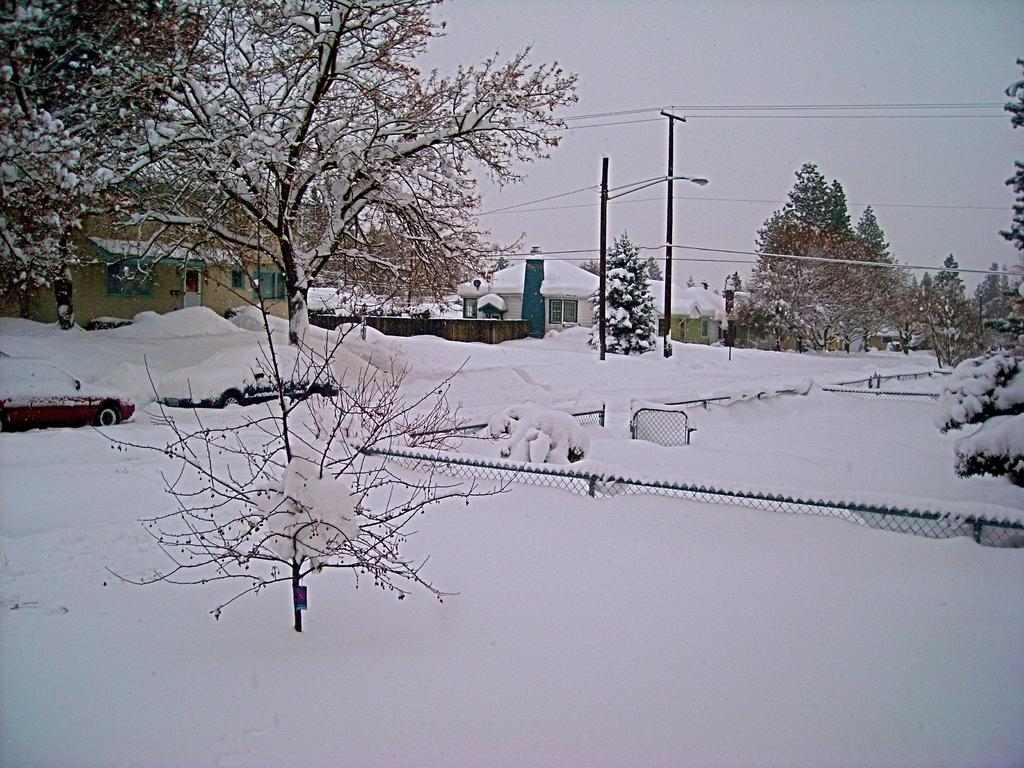What type of structures can be seen in the image? There are houses in the image. What other natural elements are present in the image? There are trees in the image. How does the weather appear to be affecting the vehicles in the image? The vehicles on the road are covered with snow. Can you see a bear sleeping on the bed in the image? There is no bed or bear present in the image. 